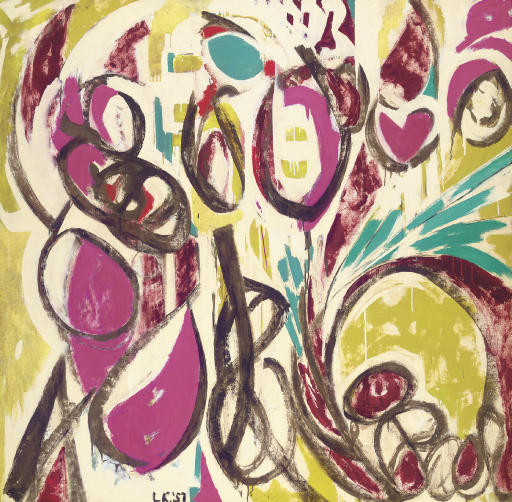What might the artist have been feeling when creating this piece? Given the intensity and vibrant nature of this piece, it's plausible that the artist was experiencing strong, possibly mixed emotions. The vigorous brushstrokes and bold color choices could indicate a burst of energy, perhaps stemming from excitement, joy, or even frustration. The chaotic yet harmonious composition might suggest a cathartic release of emotions, an attempt to visually capture the complexity of their feelings at that moment. Can you craft a short poem inspired by this artwork? In vibrant hues, the canvas sings,
A dance of forms with angel wings.
Through chaos born from wild strokes,
A harmony in color evokes.
Passion's kiss and freedom's flight,
Captured in this burst of light.  Imagine this artwork is a window to another world. Describe that world. Peering through this abstract window reveals a world where colors are alive and emotions take physical form. The sky shifts between vivid pinks and greens, with swirling patterns of energy flowing like rivers in the air. The landscape is ever-changing, composed of dynamic shapes and forms that merge and separate, dancing in a symphony of motion. It's a realm of endless creativity and expression, where the boundaries of reality are fluid, and every corner holds an explosion of life and vitality. Inhabitants of this world communicate through the shifting hues and patterns, forming a vibrant tapestry of collective emotion and thought. 